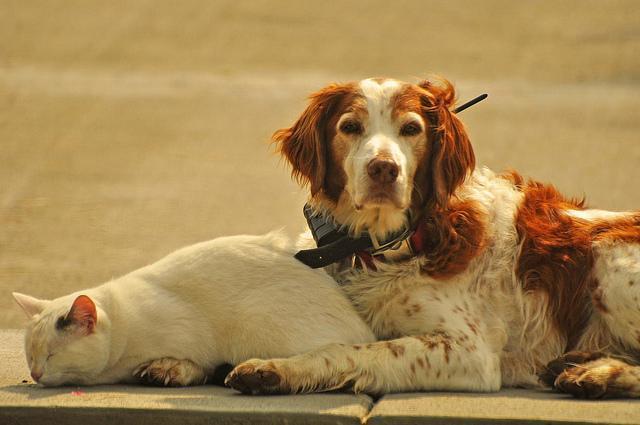How many dogs are there?
Give a very brief answer. 1. How many cats are there?
Give a very brief answer. 1. 